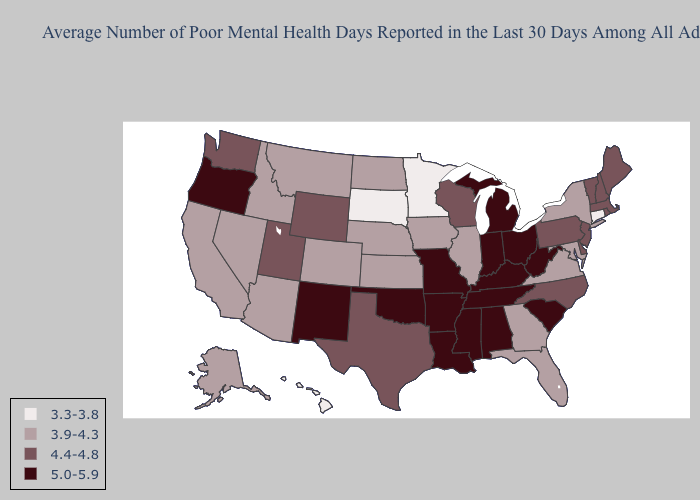What is the value of Florida?
Be succinct. 3.9-4.3. Which states hav the highest value in the MidWest?
Answer briefly. Indiana, Michigan, Missouri, Ohio. Name the states that have a value in the range 4.4-4.8?
Give a very brief answer. Delaware, Maine, Massachusetts, New Hampshire, New Jersey, North Carolina, Pennsylvania, Rhode Island, Texas, Utah, Vermont, Washington, Wisconsin, Wyoming. Does the map have missing data?
Be succinct. No. What is the lowest value in the USA?
Give a very brief answer. 3.3-3.8. How many symbols are there in the legend?
Concise answer only. 4. Name the states that have a value in the range 3.3-3.8?
Quick response, please. Connecticut, Hawaii, Minnesota, South Dakota. Name the states that have a value in the range 5.0-5.9?
Short answer required. Alabama, Arkansas, Indiana, Kentucky, Louisiana, Michigan, Mississippi, Missouri, New Mexico, Ohio, Oklahoma, Oregon, South Carolina, Tennessee, West Virginia. Which states have the lowest value in the USA?
Concise answer only. Connecticut, Hawaii, Minnesota, South Dakota. Does Hawaii have a lower value than Minnesota?
Be succinct. No. What is the highest value in the South ?
Short answer required. 5.0-5.9. Does the first symbol in the legend represent the smallest category?
Write a very short answer. Yes. What is the value of Oregon?
Be succinct. 5.0-5.9. Which states hav the highest value in the MidWest?
Give a very brief answer. Indiana, Michigan, Missouri, Ohio. What is the highest value in states that border Washington?
Answer briefly. 5.0-5.9. 